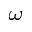Convert formula to latex. <formula><loc_0><loc_0><loc_500><loc_500>_ { \omega }</formula> 